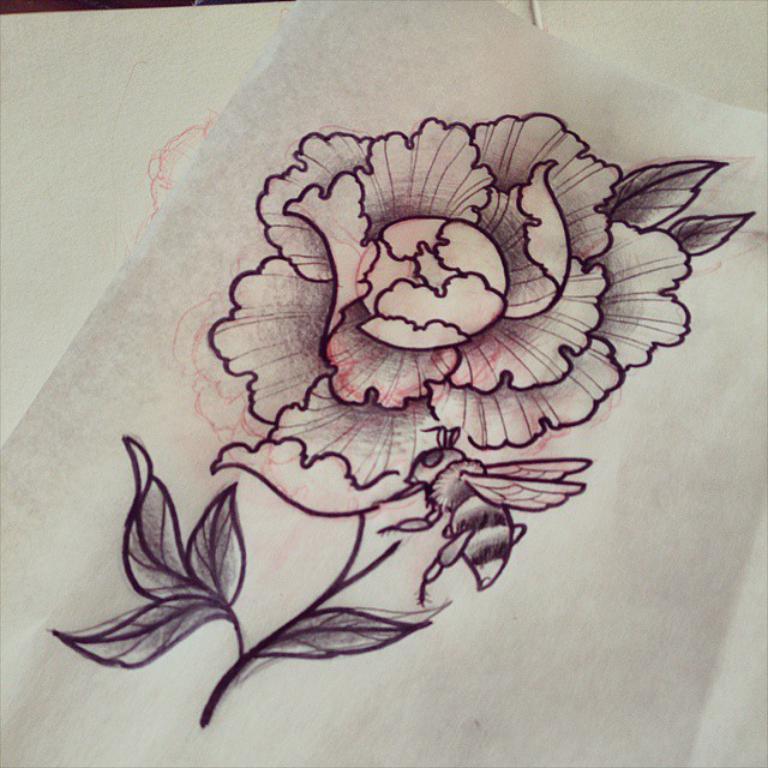In one or two sentences, can you explain what this image depicts? In this image we can see there is a sketch art on the flower. 